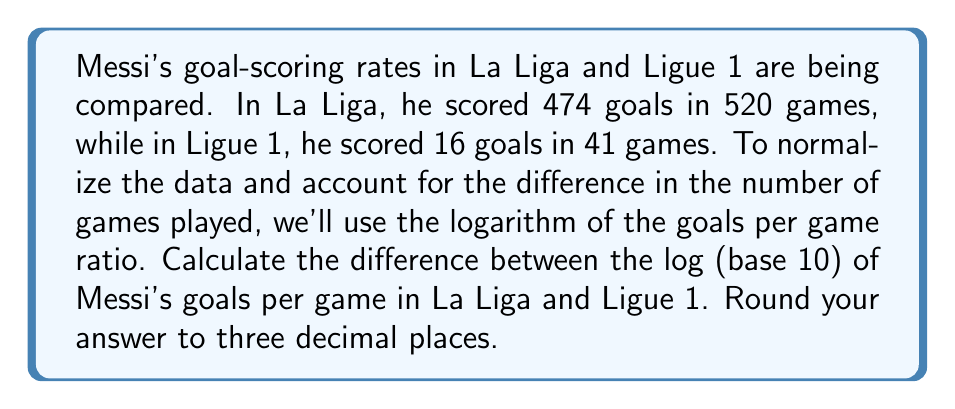Can you answer this question? 1) First, calculate the goals per game ratio for each league:

   La Liga: $\frac{474}{520} = 0.9115$ goals/game
   Ligue 1: $\frac{16}{41} = 0.3902$ goals/game

2) Take the logarithm (base 10) of each ratio:

   La Liga: $\log_{10}(0.9115) = -0.0402$
   Ligue 1: $\log_{10}(0.3902) = -0.4087$

3) Calculate the difference between the two logarithms:

   $-0.0402 - (-0.4087) = 0.3685$

4) Round to three decimal places:

   $0.369$

This logarithmic difference represents the relative performance between the two leagues, accounting for the different number of games played. A positive result indicates better performance in La Liga compared to Ligue 1.
Answer: 0.369 